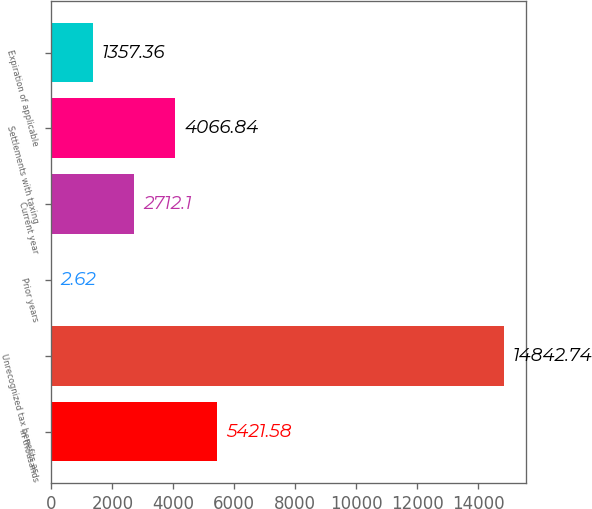Convert chart to OTSL. <chart><loc_0><loc_0><loc_500><loc_500><bar_chart><fcel>in thousands<fcel>Unrecognized tax benefits as<fcel>Prior years<fcel>Current year<fcel>Settlements with taxing<fcel>Expiration of applicable<nl><fcel>5421.58<fcel>14842.7<fcel>2.62<fcel>2712.1<fcel>4066.84<fcel>1357.36<nl></chart> 